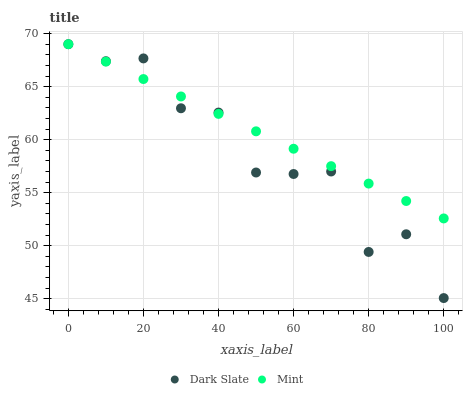Does Dark Slate have the minimum area under the curve?
Answer yes or no. Yes. Does Mint have the maximum area under the curve?
Answer yes or no. Yes. Does Mint have the minimum area under the curve?
Answer yes or no. No. Is Mint the smoothest?
Answer yes or no. Yes. Is Dark Slate the roughest?
Answer yes or no. Yes. Is Mint the roughest?
Answer yes or no. No. Does Dark Slate have the lowest value?
Answer yes or no. Yes. Does Mint have the lowest value?
Answer yes or no. No. Does Mint have the highest value?
Answer yes or no. Yes. Does Dark Slate intersect Mint?
Answer yes or no. Yes. Is Dark Slate less than Mint?
Answer yes or no. No. Is Dark Slate greater than Mint?
Answer yes or no. No. 